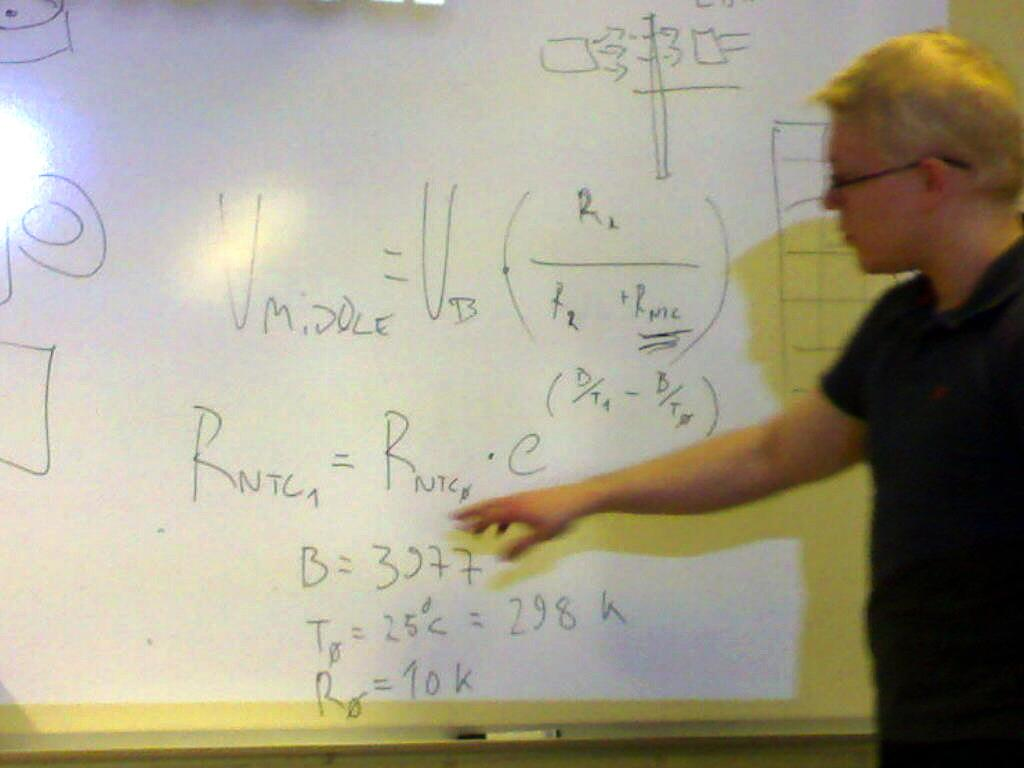<image>
Describe the image concisely. In the equation on the board B is equal to 3977 